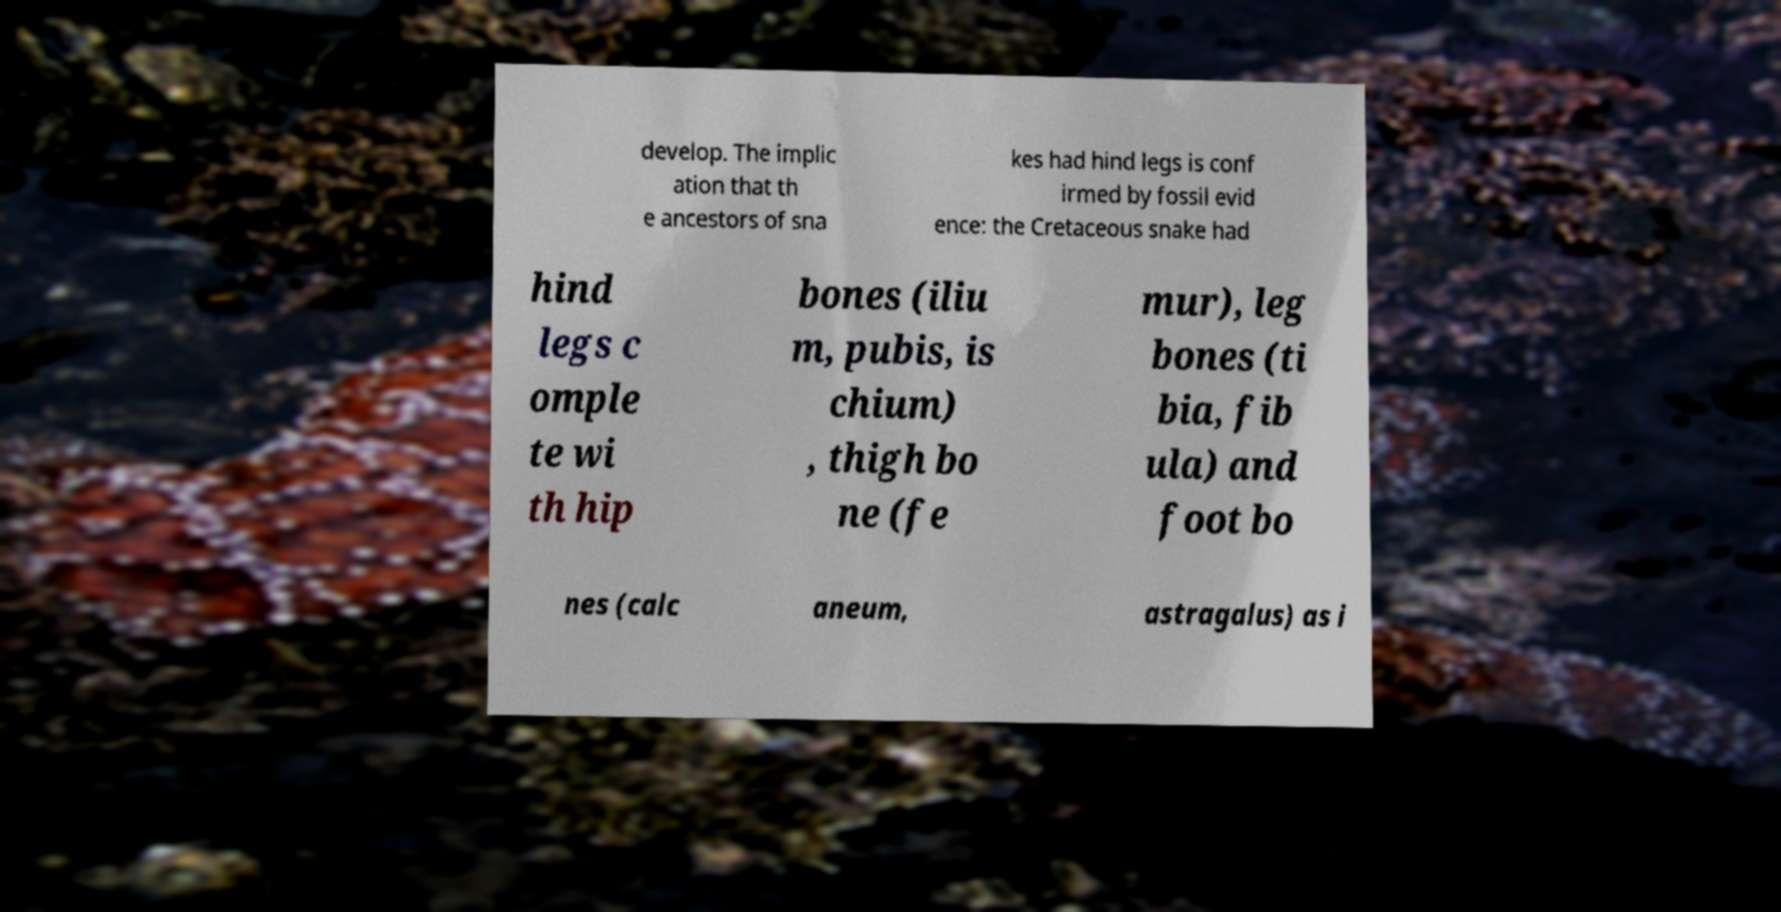Can you read and provide the text displayed in the image?This photo seems to have some interesting text. Can you extract and type it out for me? develop. The implic ation that th e ancestors of sna kes had hind legs is conf irmed by fossil evid ence: the Cretaceous snake had hind legs c omple te wi th hip bones (iliu m, pubis, is chium) , thigh bo ne (fe mur), leg bones (ti bia, fib ula) and foot bo nes (calc aneum, astragalus) as i 